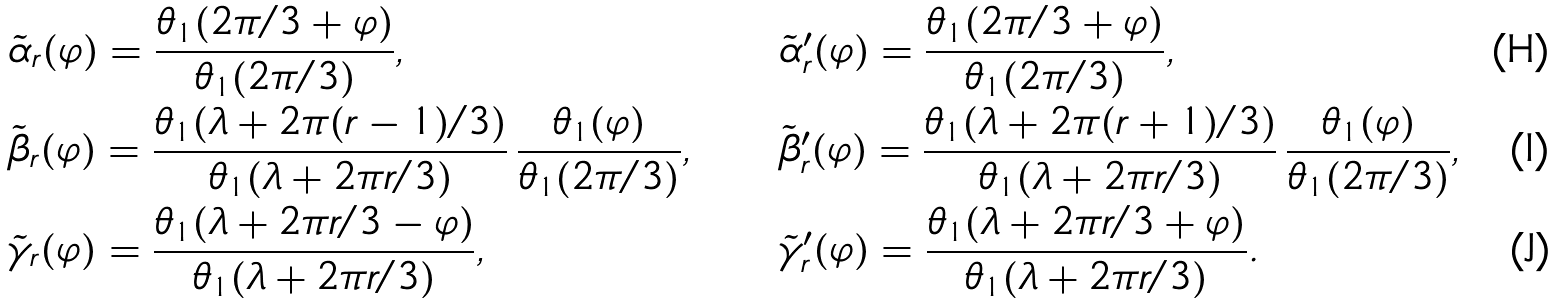Convert formula to latex. <formula><loc_0><loc_0><loc_500><loc_500>& \tilde { \alpha } _ { r } ( \varphi ) = \frac { \theta _ { 1 } ( 2 \pi / 3 + \varphi ) } { \theta _ { 1 } ( 2 \pi / 3 ) } , & & \tilde { \alpha } ^ { \prime } _ { r } ( \varphi ) = \frac { \theta _ { 1 } ( 2 \pi / 3 + \varphi ) } { \theta _ { 1 } ( 2 \pi / 3 ) } , \\ & \tilde { \beta } _ { r } ( \varphi ) = \frac { \theta _ { 1 } ( \lambda + 2 \pi ( r - 1 ) / 3 ) } { \theta _ { 1 } ( \lambda + 2 \pi r / 3 ) } \, \frac { \theta _ { 1 } ( \varphi ) } { \theta _ { 1 } ( 2 \pi / 3 ) } , & & \tilde { \beta } ^ { \prime } _ { r } ( \varphi ) = \frac { \theta _ { 1 } ( \lambda + 2 \pi ( r + 1 ) / 3 ) } { \theta _ { 1 } ( \lambda + 2 \pi r / 3 ) } \, \frac { \theta _ { 1 } ( \varphi ) } { \theta _ { 1 } ( 2 \pi / 3 ) } , \\ & \tilde { \gamma } _ { r } ( \varphi ) = \frac { \theta _ { 1 } ( \lambda + 2 \pi r / 3 - \varphi ) } { \theta _ { 1 } ( \lambda + 2 \pi r / 3 ) } , & & \tilde { \gamma } ^ { \prime } _ { r } ( \varphi ) = \frac { \theta _ { 1 } ( \lambda + 2 \pi r / 3 + \varphi ) } { \theta _ { 1 } ( \lambda + 2 \pi r / 3 ) } .</formula> 